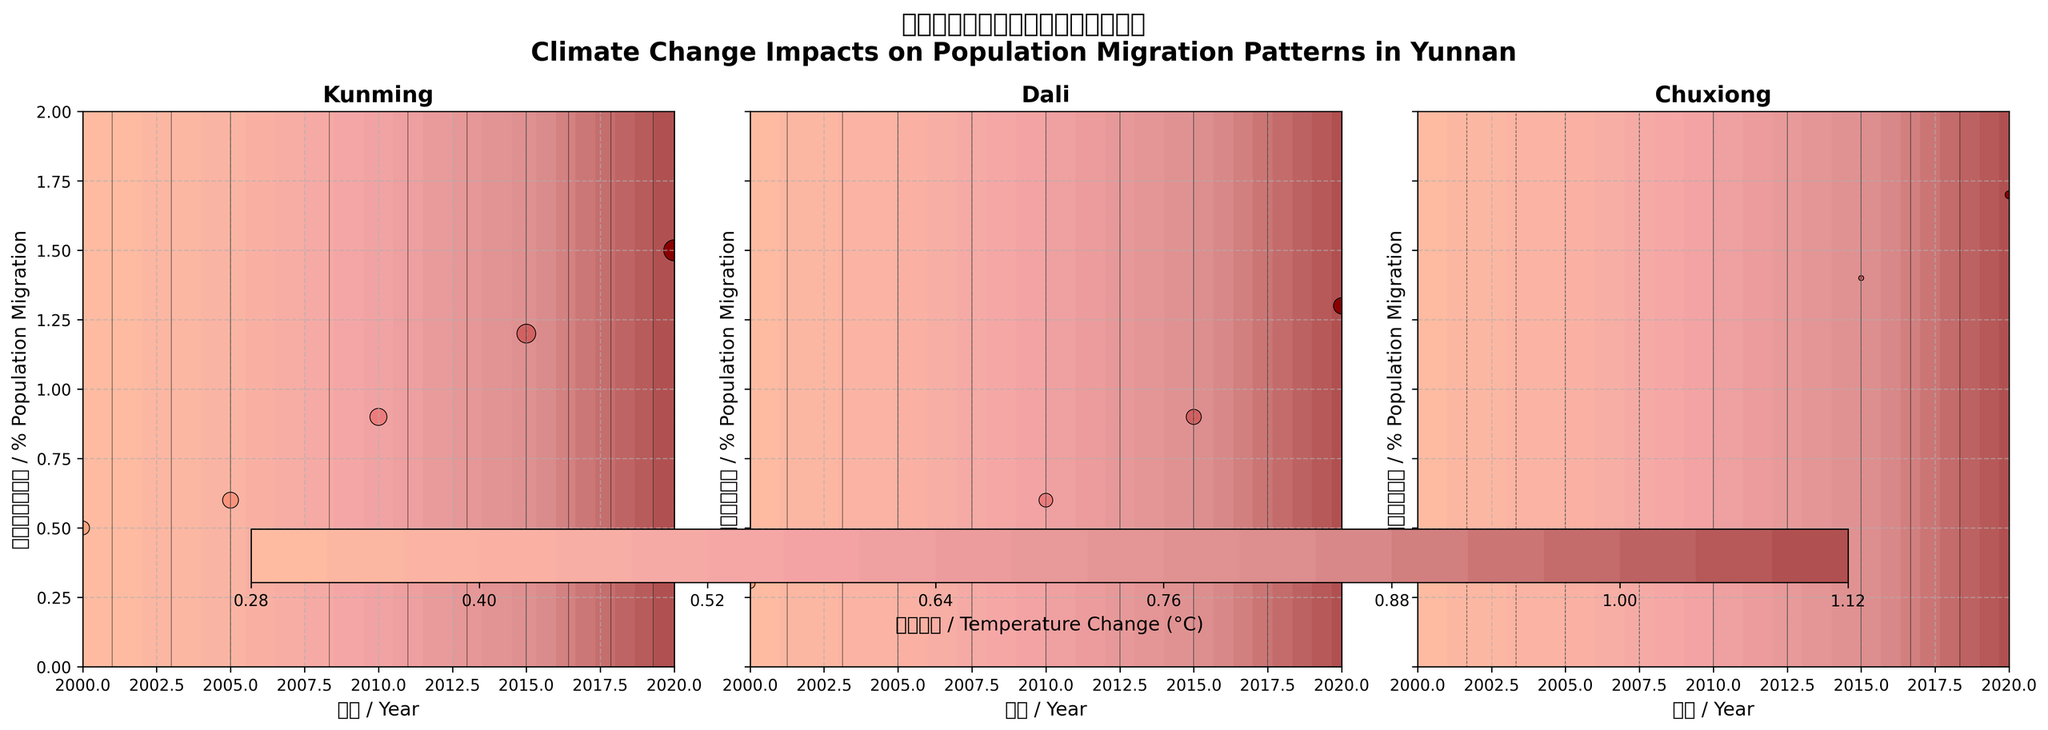Which region shows the highest percent population migration in 2020? By inspecting the figure, we can identify the regions on each subplot and look for the value in 2020. Each subplot represents a region, and we can see the data points for migration percentages. The highest value in 2020 is found in the Chuxiong subplot.
Answer: Chuxiong What is the average temperature change in Kunming across all years? To find the average temperature change for Kunming, we locate all temperature change data points in the Kunming subplot. Summing the values (0.2, 0.3, 0.5, 0.7, 1.0) and dividing by the number of data points (5), we get the average. ((0.2 + 0.3 + 0.5 + 0.7 + 1.0) / 5 = 0.54)
Answer: 0.54°C Compare the changes in precipitation between Dali and Chuxiong in 2010. Which one is higher? To compare, we look at the precipitation change for both Dali and Chuxiong in 2010. From the subplots, Dali shows a precipitation change of 1.5 while Chuxiong shows a value of 0.0. Therefore, Dali has a higher precipitation change in 2010.
Answer: Dali Which region has the most noticeable upward trend in population migration percentage over the years? To identify the trend, we can visually inspect each subplot and observe the trajectory of the scatter plot points over time. Chuxiong shows the steepest upward trend in population migration percentage from 2000 to 2020.
Answer: Chuxiong How does temperature change affect the population migration percentage in Kunming? By examining Kunming's subplot, we see that as the temperature change increases over the years, the percentage of population migration also increases, indicating a positive correlation.
Answer: Positive correlation What is the temperature change in Dali in 2015 compared to 2000? To find this, look at the temperature change value for Dali in 2015 (0.6) and in 2000 (0.1), then calculate the difference: 0.6 - 0.1 = 0.5.
Answer: 0.5°C What percentage of the population migrated from Chuxiong in 2005? By examining the data points in the Chuxiong subplot, we find that the percent population migration in 2005 is 0.8%.
Answer: 0.8% Is there a significant difference in precipitation change between Kunming and Dali in 2000? To determine the difference, check the precipitation change in 2000 for both Kunming (1.5) and Dali (0.8). The difference is calculated as 1.5 - 0.8 = 0.7, which is relatively significant.
Answer: Yes, 0.7 Which year does Kunming reach a population migration percentage of 1.2%? By locating the value in Kunming's subplot, we find that the 1.2% migration rate is reached in the year 2015.
Answer: 2015 In Chuxiong, how does the trend in precipitation change compare to temperature change over the years? Inspecting Chuxiong's subplot, we see that the temperature change increases steadily, while the precipitation change has a very moderate increase, almost flat by comparison.
Answer: Temperature change increases, precipitation is relatively flat 